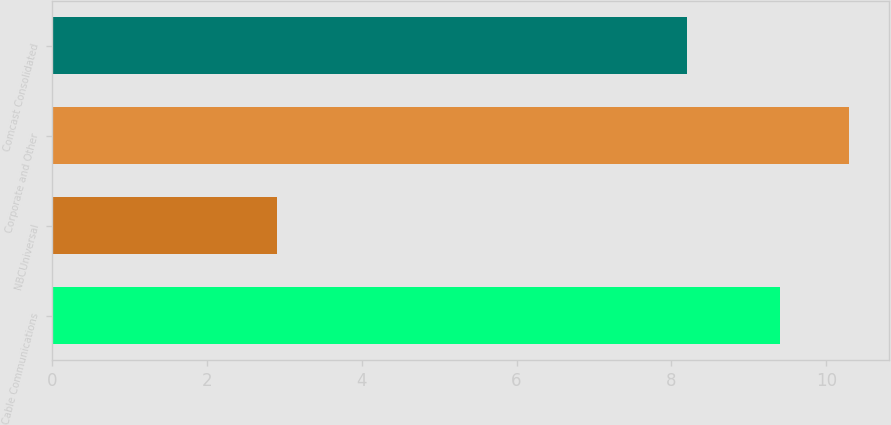Convert chart. <chart><loc_0><loc_0><loc_500><loc_500><bar_chart><fcel>Cable Communications<fcel>NBCUniversal<fcel>Corporate and Other<fcel>Comcast Consolidated<nl><fcel>9.4<fcel>2.9<fcel>10.3<fcel>8.2<nl></chart> 